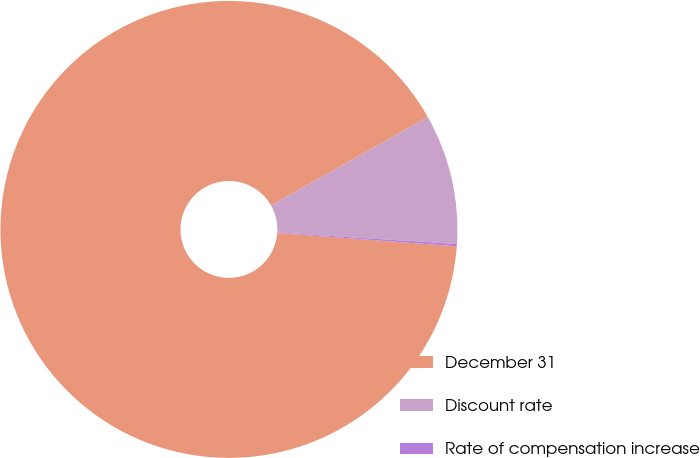<chart> <loc_0><loc_0><loc_500><loc_500><pie_chart><fcel>December 31<fcel>Discount rate<fcel>Rate of compensation increase<nl><fcel>90.64%<fcel>9.21%<fcel>0.16%<nl></chart> 